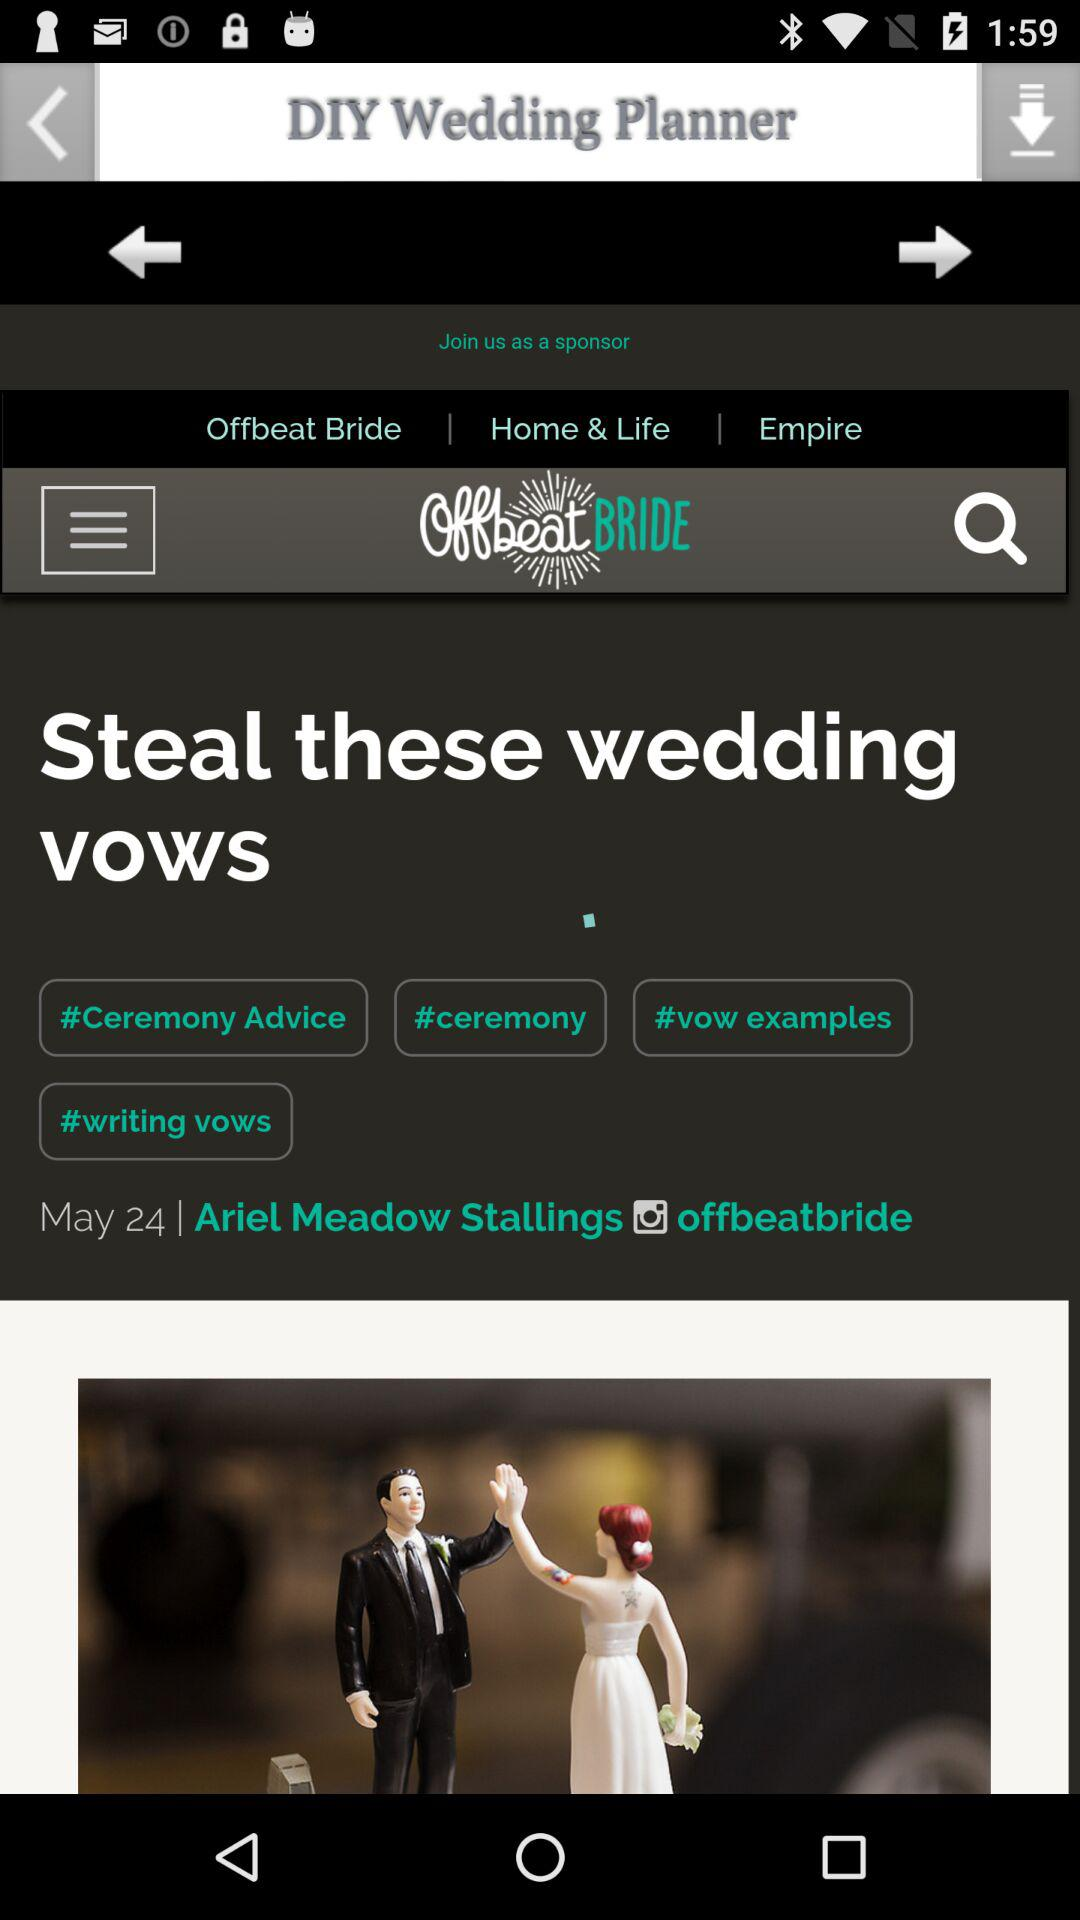What is the publication date of "Steal these wedding vows"? The publication date of "Steal these wedding vows" is May 24. 